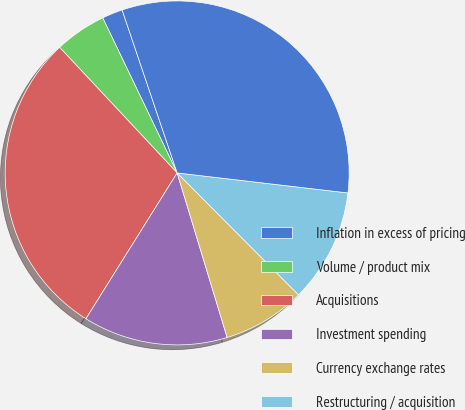<chart> <loc_0><loc_0><loc_500><loc_500><pie_chart><fcel>Inflation in excess of pricing<fcel>Volume / product mix<fcel>Acquisitions<fcel>Investment spending<fcel>Currency exchange rates<fcel>Restructuring / acquisition<fcel>Total<nl><fcel>1.94%<fcel>4.85%<fcel>29.13%<fcel>13.59%<fcel>7.77%<fcel>10.68%<fcel>32.04%<nl></chart> 